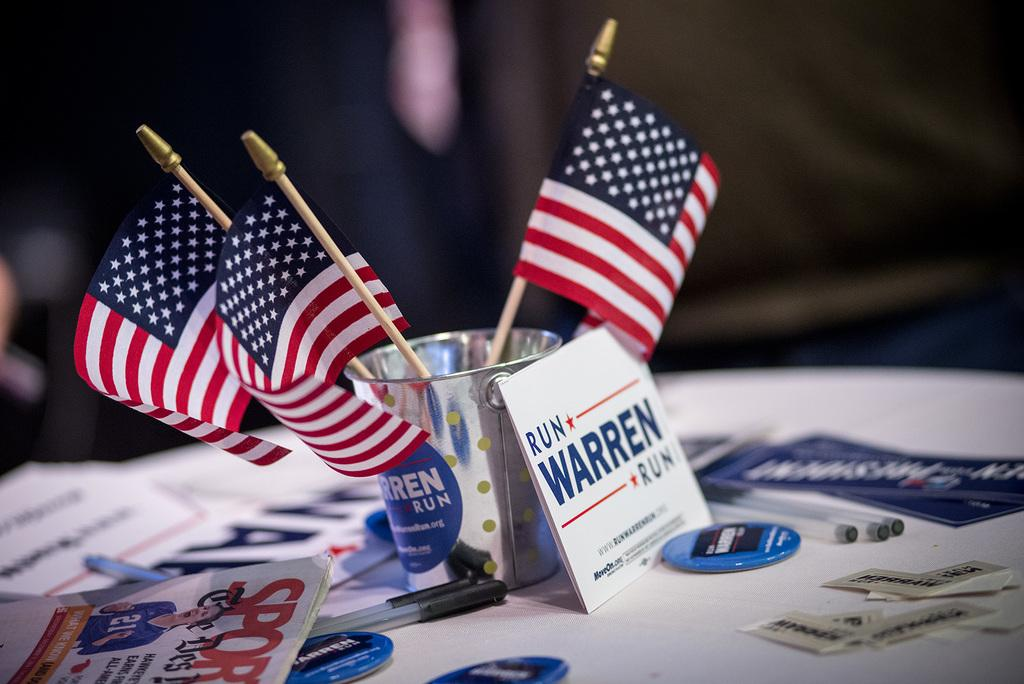What is in the cup that is visible in the image? There are three small US flags in the cup. What other items can be seen in the image? There are pens and papers visible in the image. What color is the table in the image? The table is white in color. Is the boat in the image making any noise? There is no boat present in the image, so it cannot be making any noise. 